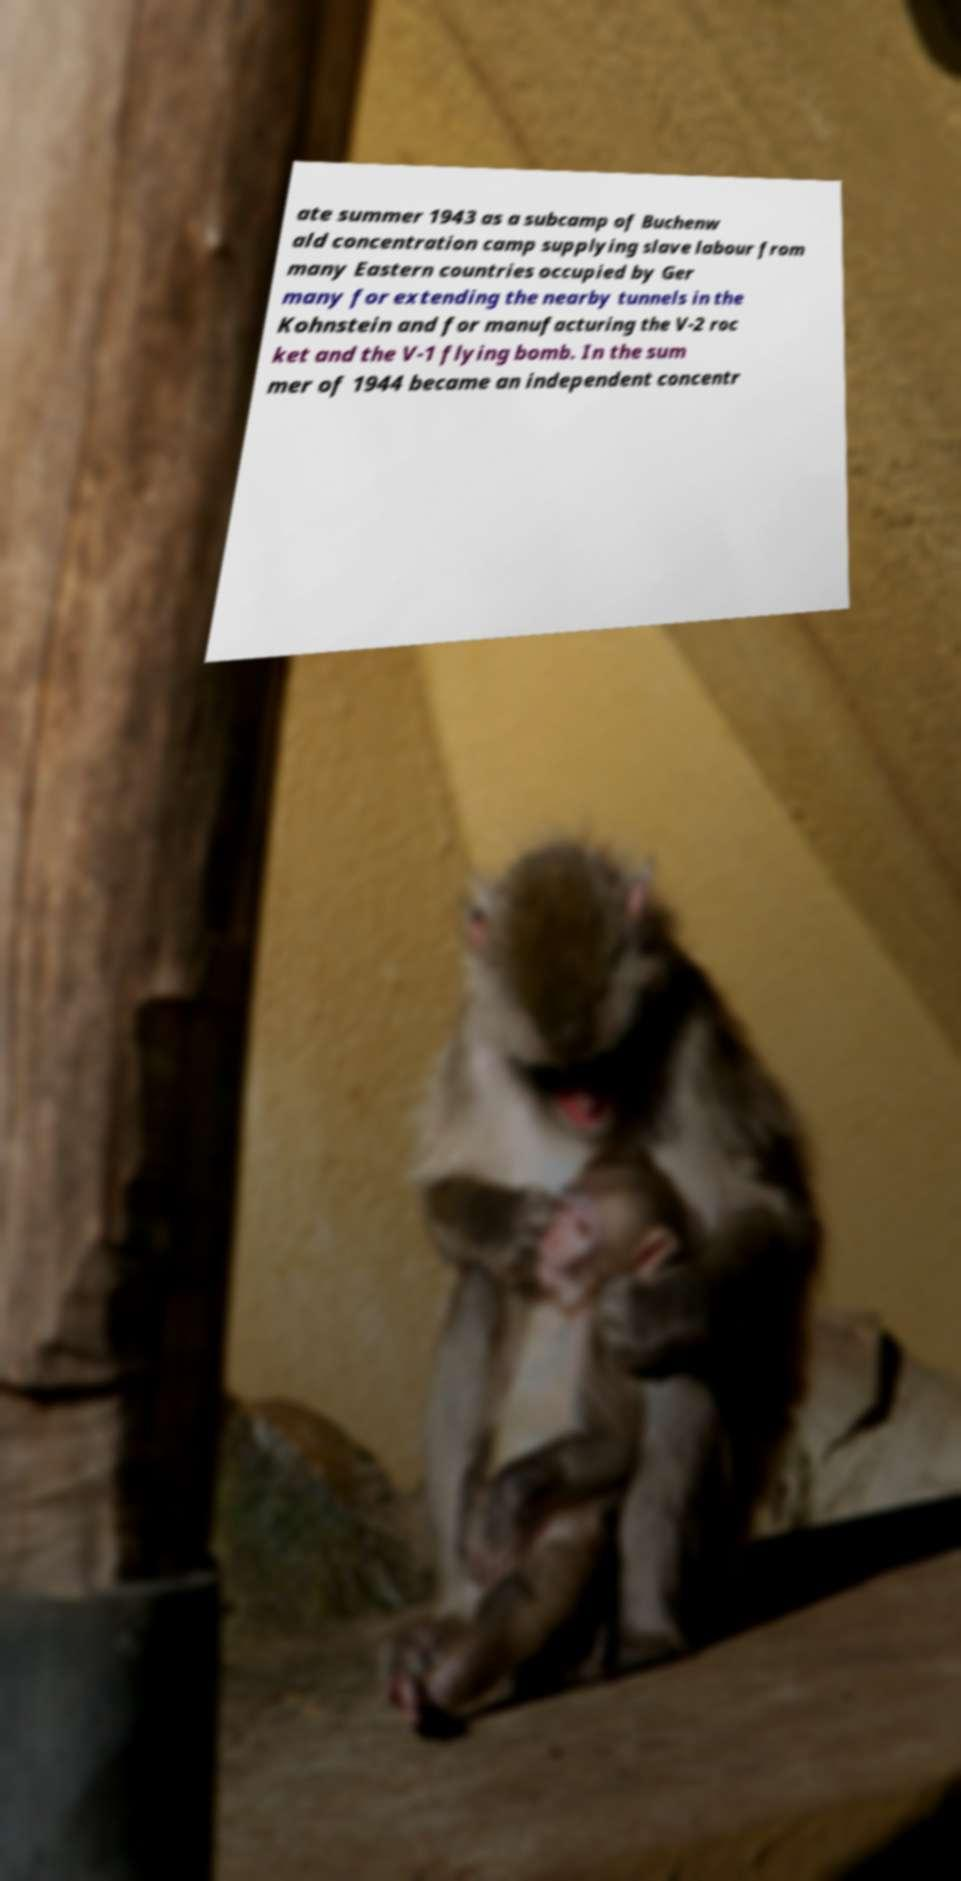Could you assist in decoding the text presented in this image and type it out clearly? ate summer 1943 as a subcamp of Buchenw ald concentration camp supplying slave labour from many Eastern countries occupied by Ger many for extending the nearby tunnels in the Kohnstein and for manufacturing the V-2 roc ket and the V-1 flying bomb. In the sum mer of 1944 became an independent concentr 